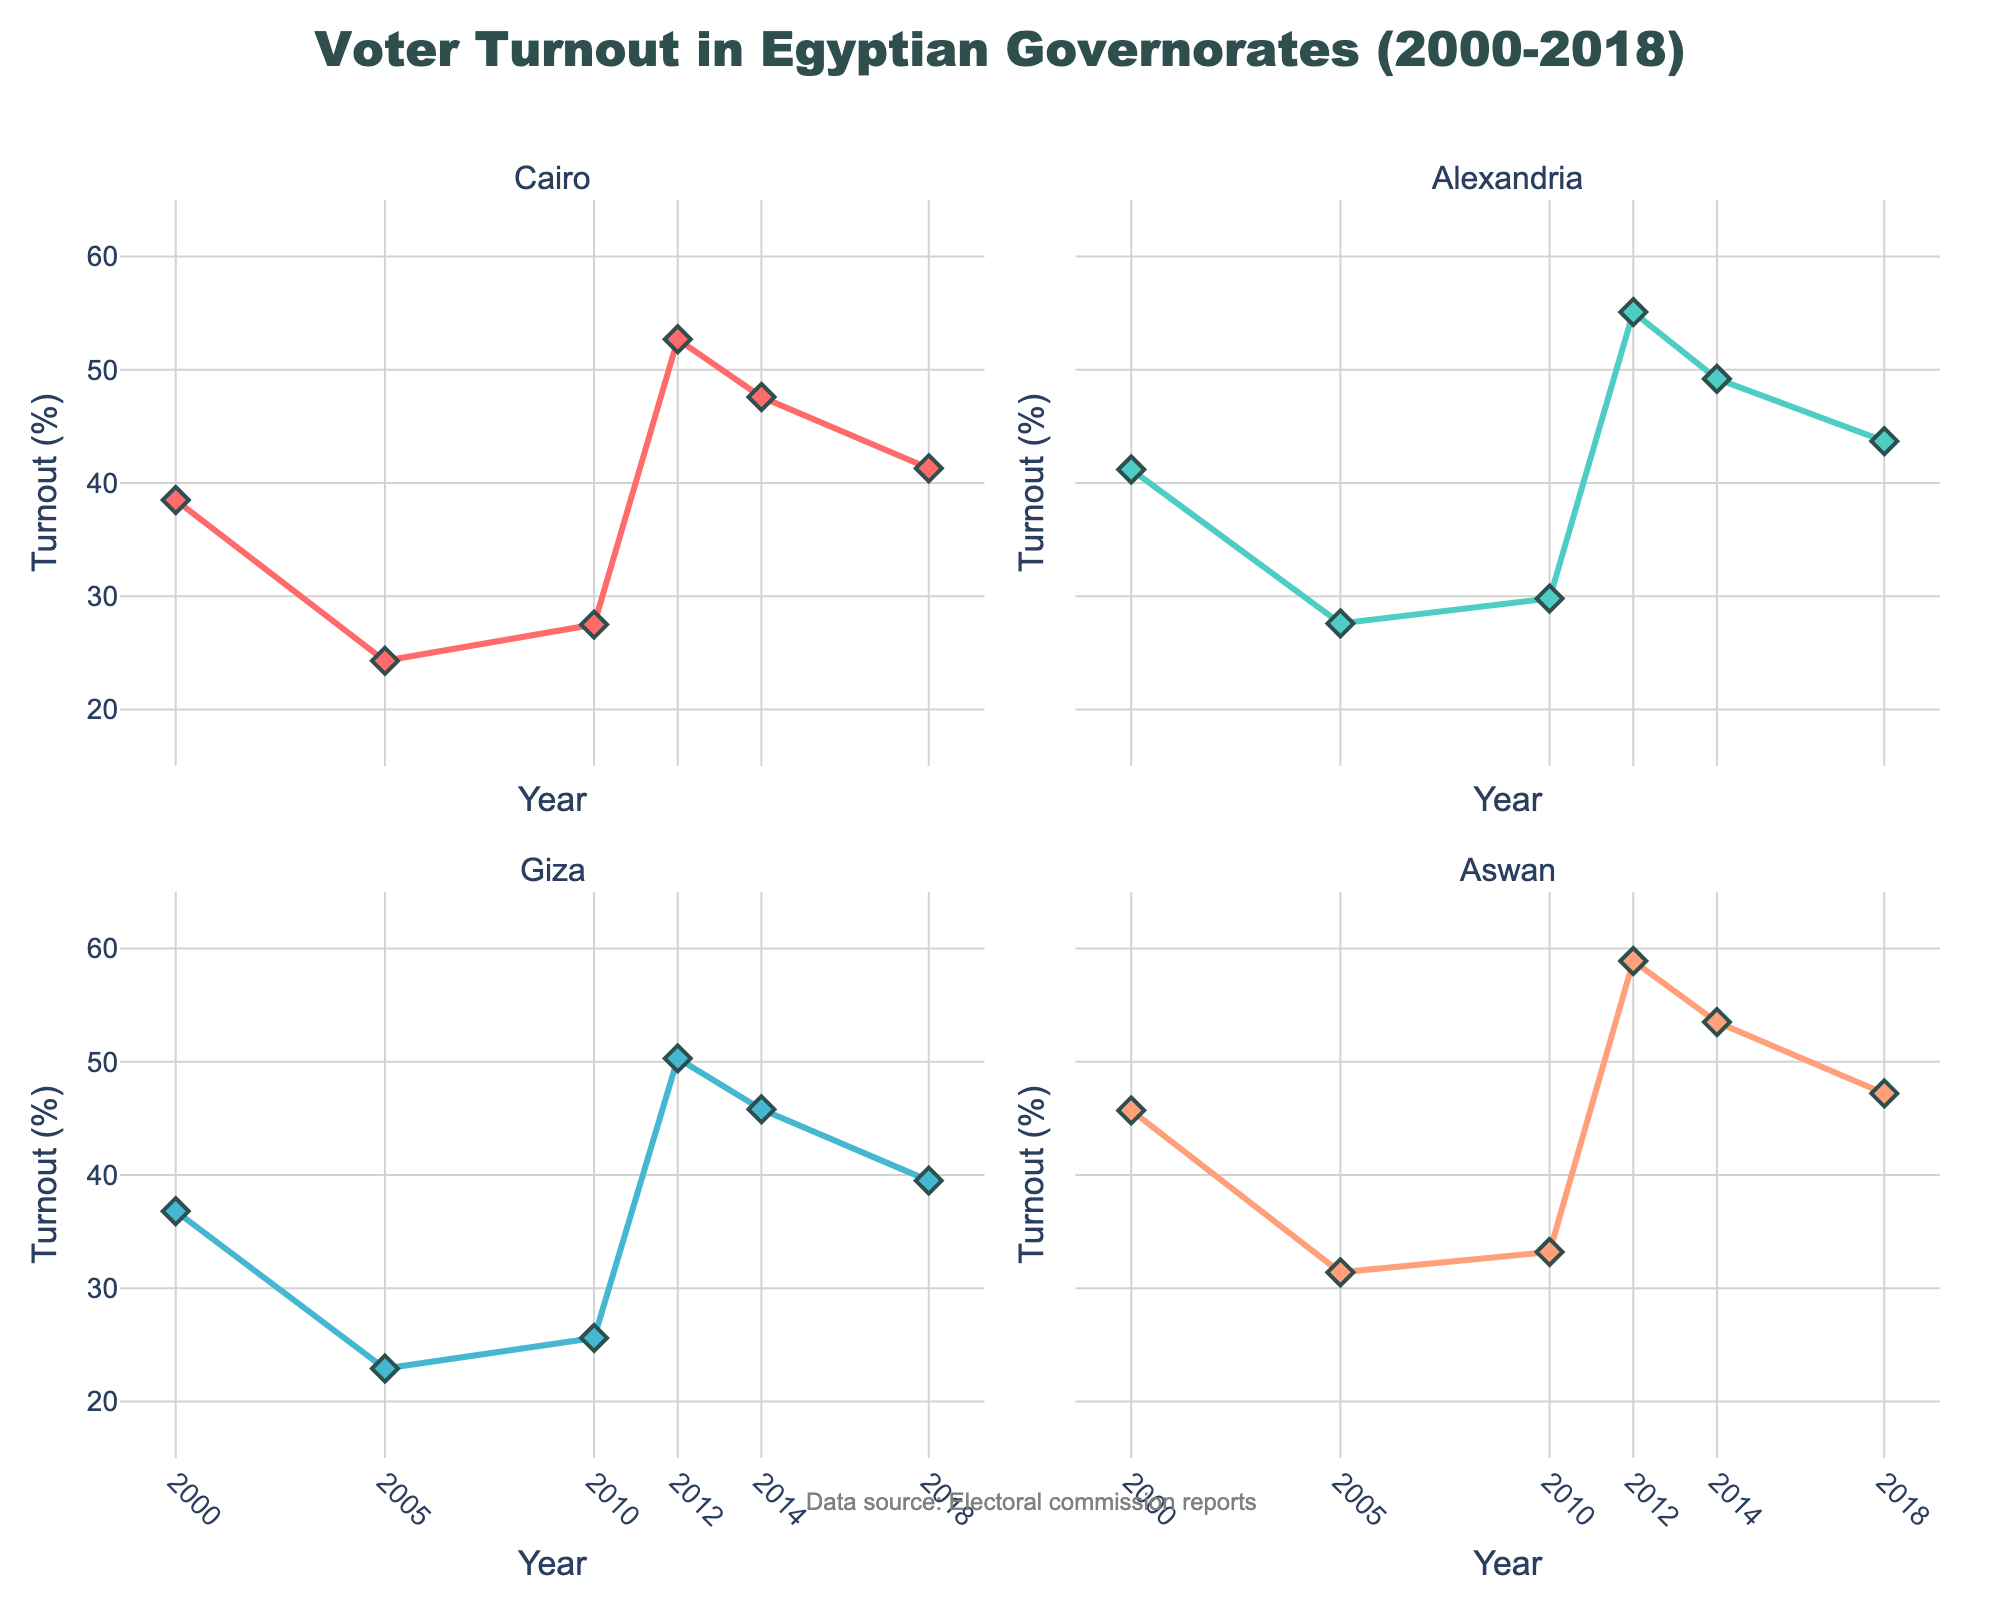What is the title of the chart? The title is usually placed at the top of the figure. In this case, it is "Voter Turnout in Egyptian Governorates (2000-2018)."
Answer: Voter Turnout in Egyptian Governorates (2000-2018) What are the y-axis labels for each subplot? Each y-axis label is located on the left side of the respective subplot. The label reads “Turnout (%)” for all subplots.
Answer: Turnout (%) Which governorate had the highest voter turnout in 2012? Look at the data points for the year 2012 in each subplot. Aswan has the highest turnout at 58.9%.
Answer: Aswan How did voter turnout in Giza change from 2014 to 2018? Compare the data points for Giza from 2014 (45.8%) and 2018 (39.5%). The turnout decreased by 6.3%.
Answer: Decreased by 6.3% Which year had the lowest voter turnout in Cairo? Look at the data points in the Cairo subplot and identify the lowest value. The year 2005 had the lowest turnout at 24.3%.
Answer: 2005 What is the overall trend in voter turnout in Alexandria from 2000 to 2018? Looking at the line graph for Alexandria, the voter turnout has fluctuated but generally increased from 41.2% in 2000 to 43.7% in 2018.
Answer: Generally increased Which governorate saw the most significant increase in voter turnout between 2005 and 2012? Calculate the difference between turnout values for 2005 and 2012 for each governorate. Aswan saw the most significant increase of 27.5% (from 31.4% to 58.9%).
Answer: Aswan How many total data points are there in each subplot? Each subplot consists of one data point for every election year shown in the figure: 2000, 2005, 2010, 2012, 2014, and 2018. Therefore, each subplot has 6 data points.
Answer: 6 In which years did Cairo experience a voter turnout above 40%? Identify the years in the Cairo subplot where the turnout is above 40%. The years are 2012, 2014, and 2018.
Answer: 2012, 2014, 2018 Which governorate experienced a smaller change in voter turnout from 2010 to 2014 when compared to Alexandria? Calculate the change in turnout for Alexandria from 2010 to 2014 (49.2% - 29.8% = 19.4%). Compare this with other governorates: Cairo (20.1%), Giza (20.2%), and Aswan (20.3%). Alexandria's change is smaller than all other governorates.
Answer: Alexandria 